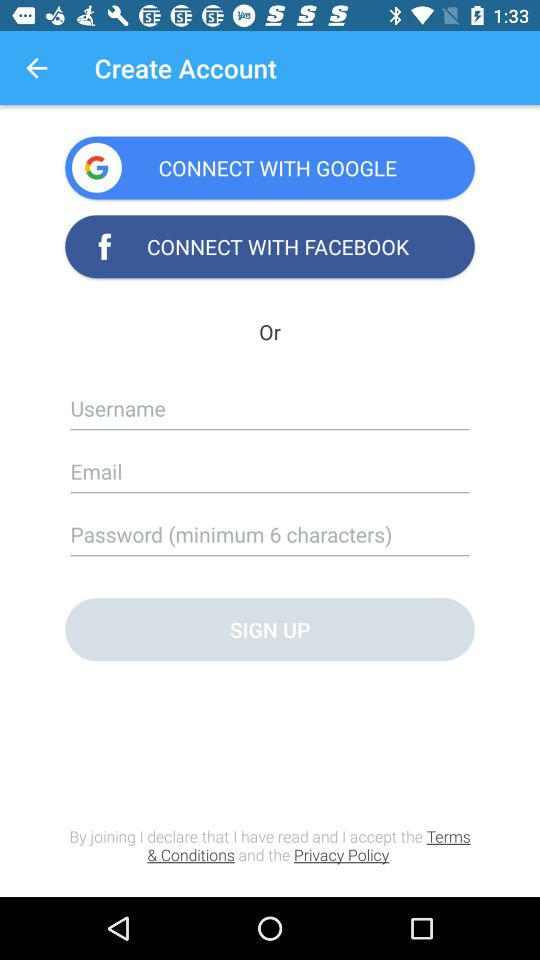How many text inputs are there for entering information?
Answer the question using a single word or phrase. 3 